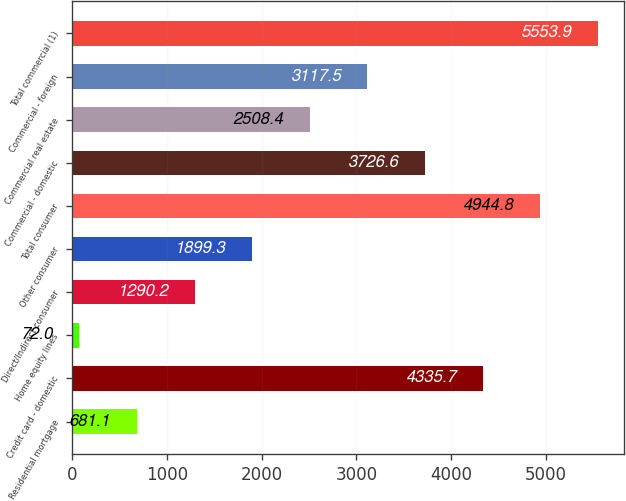Convert chart to OTSL. <chart><loc_0><loc_0><loc_500><loc_500><bar_chart><fcel>Residential mortgage<fcel>Credit card - domestic<fcel>Home equity lines<fcel>Direct/Indirect consumer<fcel>Other consumer<fcel>Total consumer<fcel>Commercial - domestic<fcel>Commercial real estate<fcel>Commercial - foreign<fcel>Total commercial (1)<nl><fcel>681.1<fcel>4335.7<fcel>72<fcel>1290.2<fcel>1899.3<fcel>4944.8<fcel>3726.6<fcel>2508.4<fcel>3117.5<fcel>5553.9<nl></chart> 